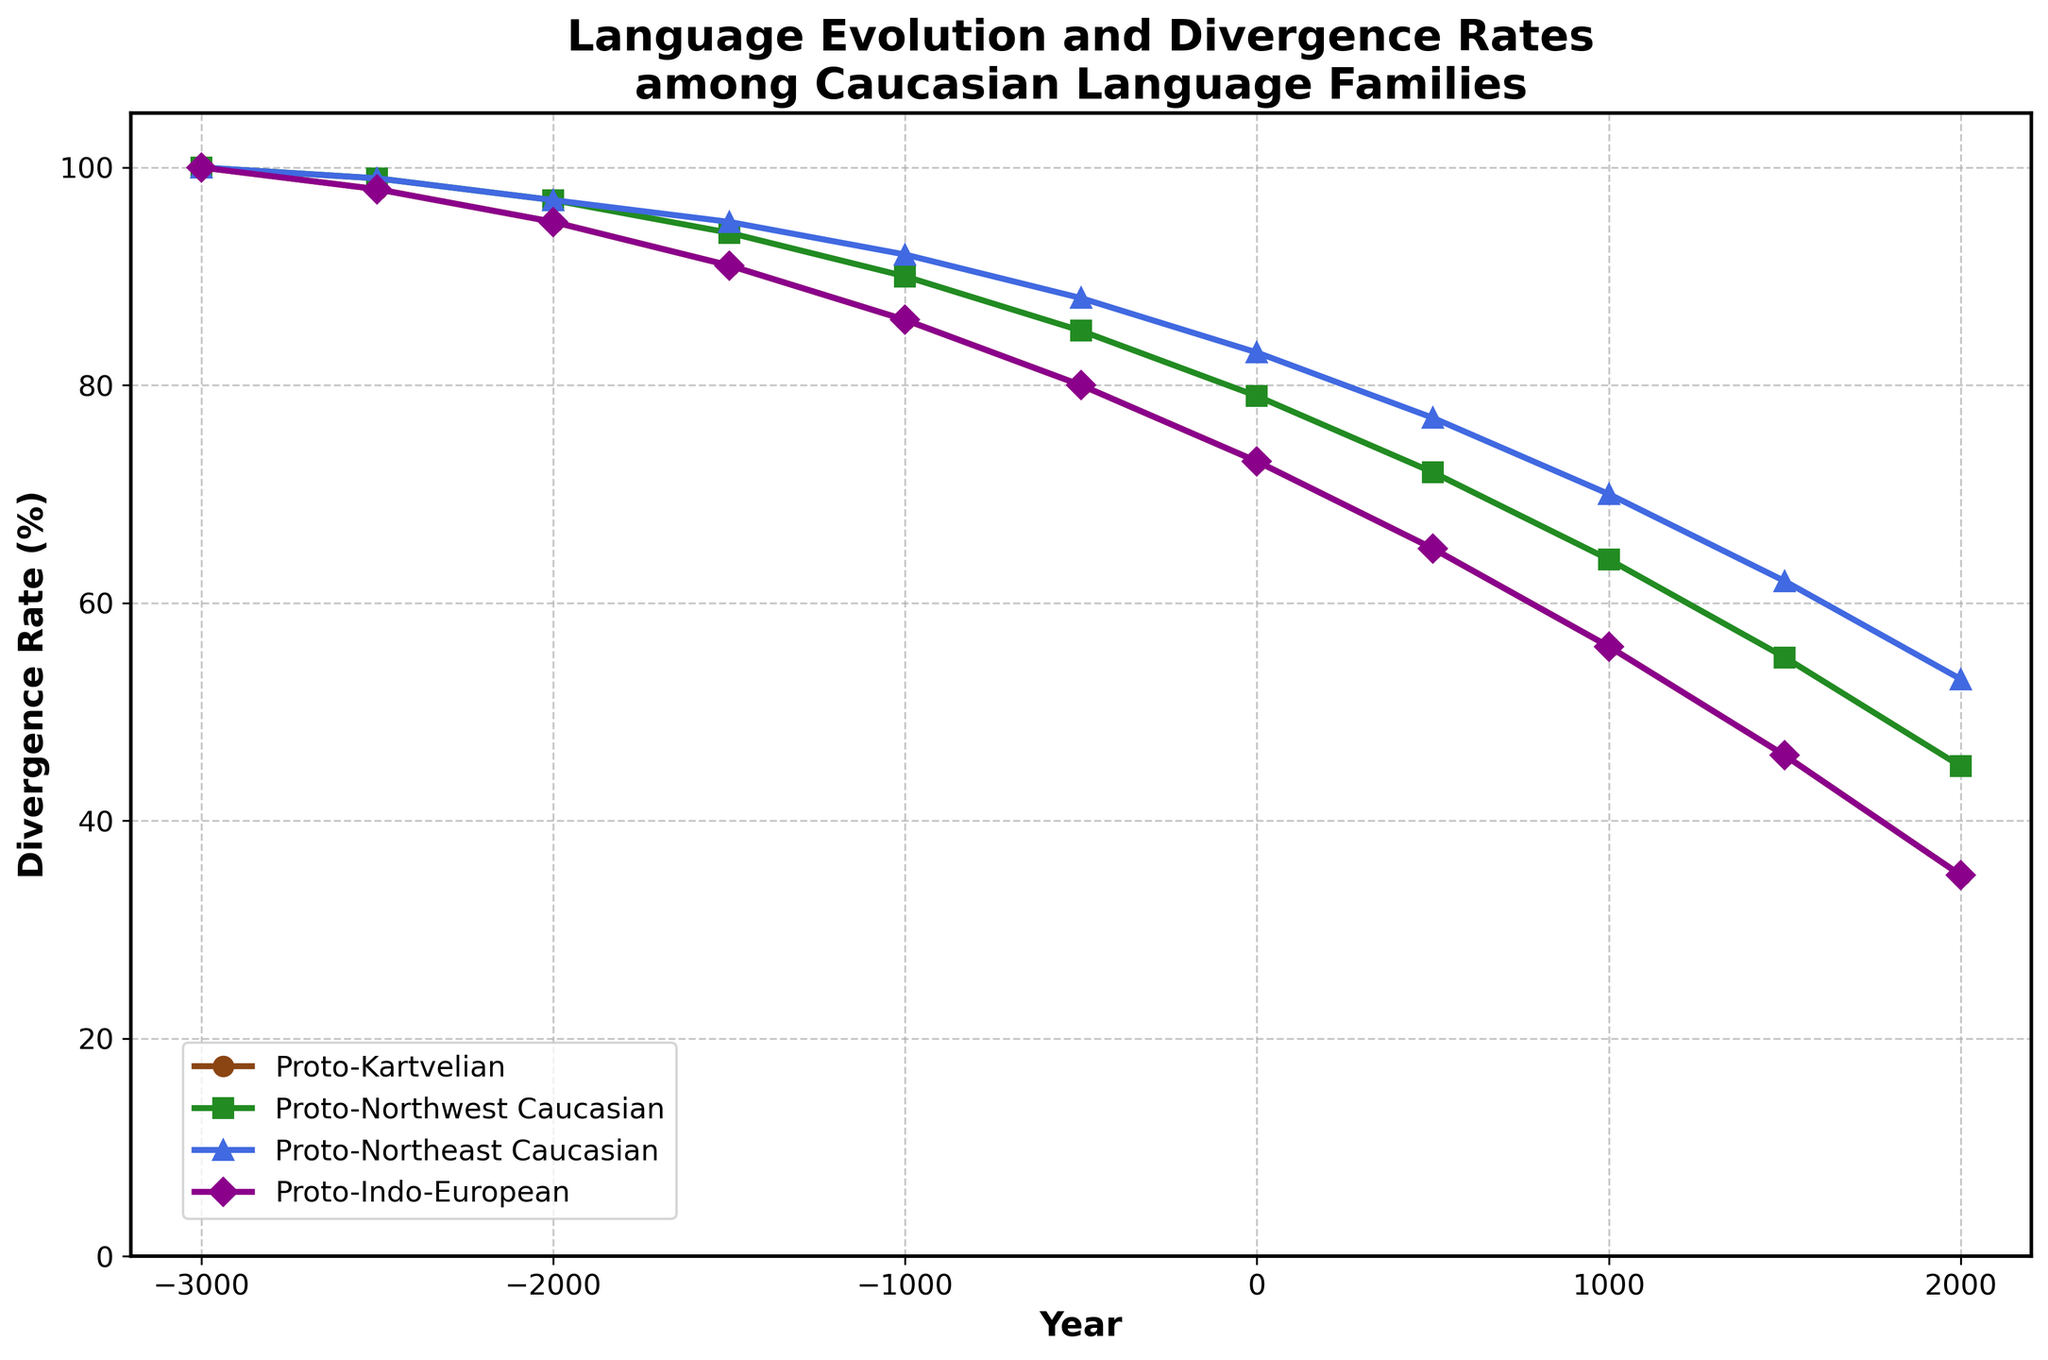What year does the Proto-Kartvelian language diverge to 86%? To find out, we need to look at the point where the Proto-Kartvelian curve intersects the 86% level. According to the plot, this occurs around -1000 BCE.
Answer: -1000 BCE Which language family had the highest divergence rate in 0 CE? To determine this, we need to compare the divergence rates of all language families in 0 CE. The Proto-Northeast Caucasian language family had the highest divergence rate of 83% in that year.
Answer: Proto-Northeast Caucasian Over which period did the Proto-Indo-European language divergence decrease from 95% to 46%? Identify the years at which the Proto-Indo-European language had 95% and 46% divergence, and find the interval between these years. It decreased from 95% at -2000 BCE to 46% at 1500 CE.
Answer: -2000 BCE to 1500 CE What is the average divergence rate of Proto-Northwest Caucasian language over the recorded period? First, extract the divergence rates at each specified year for Proto-Northwest Caucasian (100, 99, 97, 94, 90, 85, 79, 72, 64, 55, 45). Sum these values and divide by the total number of years (11). Average = (100 + 99 + 97 + 94 + 90 + 85 + 79 + 72 + 64 + 55 + 45) / 11 = 880 / 11 = 80.
Answer: 80 Between -500 BCE and 500 CE, which language family's divergence rate changed the most? Calculate the change in divergence rate for each language family within the interval -500 BCE to 500 CE. Proto-Kartvelian changed from 80% to 65% (-15%), Proto-Northwest Caucasian changed from 85% to 72% (-13%), Proto-Northeast Caucasian changed from 88% to 77% (-11%), Proto-Indo-European changed from 80% to 65% (-15%). Proto-Kartvelian and Proto-Indo-European had the most change.
Answer: Proto-Kartvelian and Proto-Indo-European Which language family shows the least divergence rate decline from -3000 BCE to 2000 CE? Extract the divergence rates at -3000 BCE and 2000 CE for each language family. Calculate the decline for each (Proto-Kartvelian: 100 - 35 = 65, Proto-Northwest Caucasian: 100 - 45 = 55, Proto-Northeast Caucasian: 100 - 53 = 47, Proto-Indo-European: 100 - 35 = 65). Proto-Northeast Caucasian shows the least decline.
Answer: Proto-Northeast Caucasian At 1500 CE, which language family had the smallest divergence rate? Look at the divergence rates at 1500 CE for all language families, which are Proto-Kartvelian: 46%, Proto-Northwest Caucasian: 55%, Proto-Northeast Caucasian: 62%, Proto-Indo-European: 46%. Both Proto-Kartvelian and Proto-Indo-European had the smallest rate with 46%.
Answer: Proto-Kartvelian and Proto-Indo-European What is the color of the line representing the Proto-Northeast Caucasian language family? Reference the color of the line associated with the Proto-Northeast Caucasian language family. The line color is blue.
Answer: Blue From 0 CE to 1000 CE, by how much did the divergence rate of Proto-Kartvelian decline? Calculate the difference in the divergence rate of Proto-Kartvelian between 0 CE (73%) and 1000 CE (56%). Therefore, 73% - 56% = 17%.
Answer: 17% 